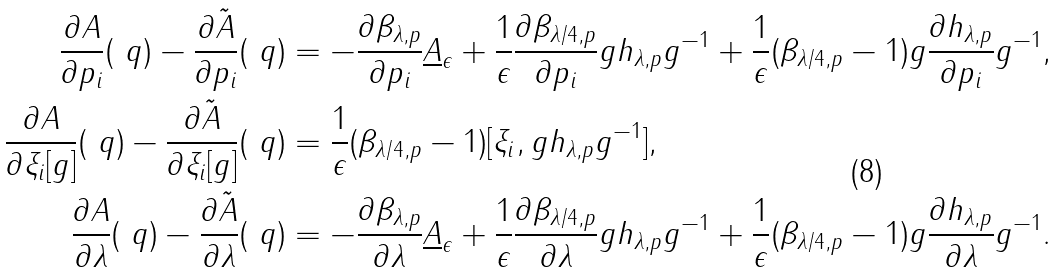<formula> <loc_0><loc_0><loc_500><loc_500>\frac { \partial A } { \partial p _ { i } } ( \ q ) - \frac { \partial \tilde { A } } { \partial p _ { i } } ( \ q ) & = - \frac { \partial \beta _ { \lambda , p } } { \partial p _ { i } } \underline { A } _ { \epsilon } + \frac { 1 } { \epsilon } \frac { \partial \beta _ { \lambda / 4 , p } } { \partial p _ { i } } g h _ { \lambda , p } g ^ { - 1 } + \frac { 1 } { \epsilon } ( \beta _ { \lambda / 4 , p } - 1 ) g \frac { \partial h _ { \lambda , p } } { \partial p _ { i } } g ^ { - 1 } , \\ \frac { \partial A } { \partial \xi _ { i } [ g ] } ( \ q ) - \frac { \partial \tilde { A } } { \partial \xi _ { i } [ g ] } ( \ q ) & = \frac { 1 } { \epsilon } ( \beta _ { \lambda / 4 , p } - 1 ) [ \xi _ { i } , g h _ { \lambda , p } g ^ { - 1 } ] , \\ \frac { \partial A } { \partial \lambda } ( \ q ) - \frac { \partial \tilde { A } } { \partial \lambda } ( \ q ) & = - \frac { \partial \beta _ { \lambda , p } } { \partial \lambda } \underline { A } _ { \epsilon } + \frac { 1 } { \epsilon } \frac { \partial \beta _ { \lambda / 4 , p } } { \partial \lambda } g h _ { \lambda , p } g ^ { - 1 } + \frac { 1 } { \epsilon } ( \beta _ { \lambda / 4 , p } - 1 ) g \frac { \partial h _ { \lambda , p } } { \partial \lambda } g ^ { - 1 } .</formula> 